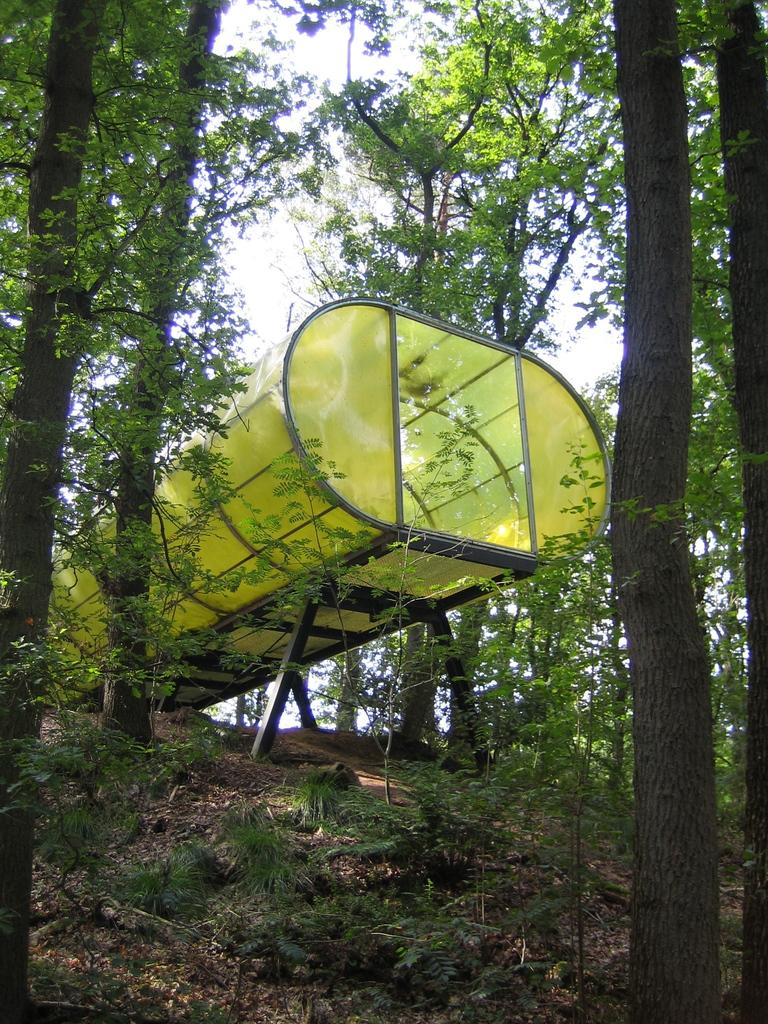What structure is present in the image? There is a shed in the image. What is the color of the shed? The shed is green in color. What can be seen in the background of the image? There are trees in the background of the image. What is the color of the trees? The trees are green in color. What else is visible in the image? The sky is visible in the image. What is the color of the sky? The sky is white in color. Is there a hat on the shed to celebrate someone's birthday in the image? There is no hat or indication of a birthday celebration present in the image. 